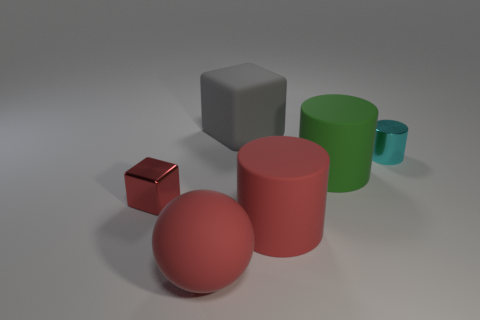Are there any spheres that have the same material as the small block? Upon examining the image, it appears that the small block and the spheres have distinct materials. The spheres have a matte finish with a uniform color, while the small block has a reflective, metallic sheen. So, to answer your question, there are no spheres that share the same material as the small block. 